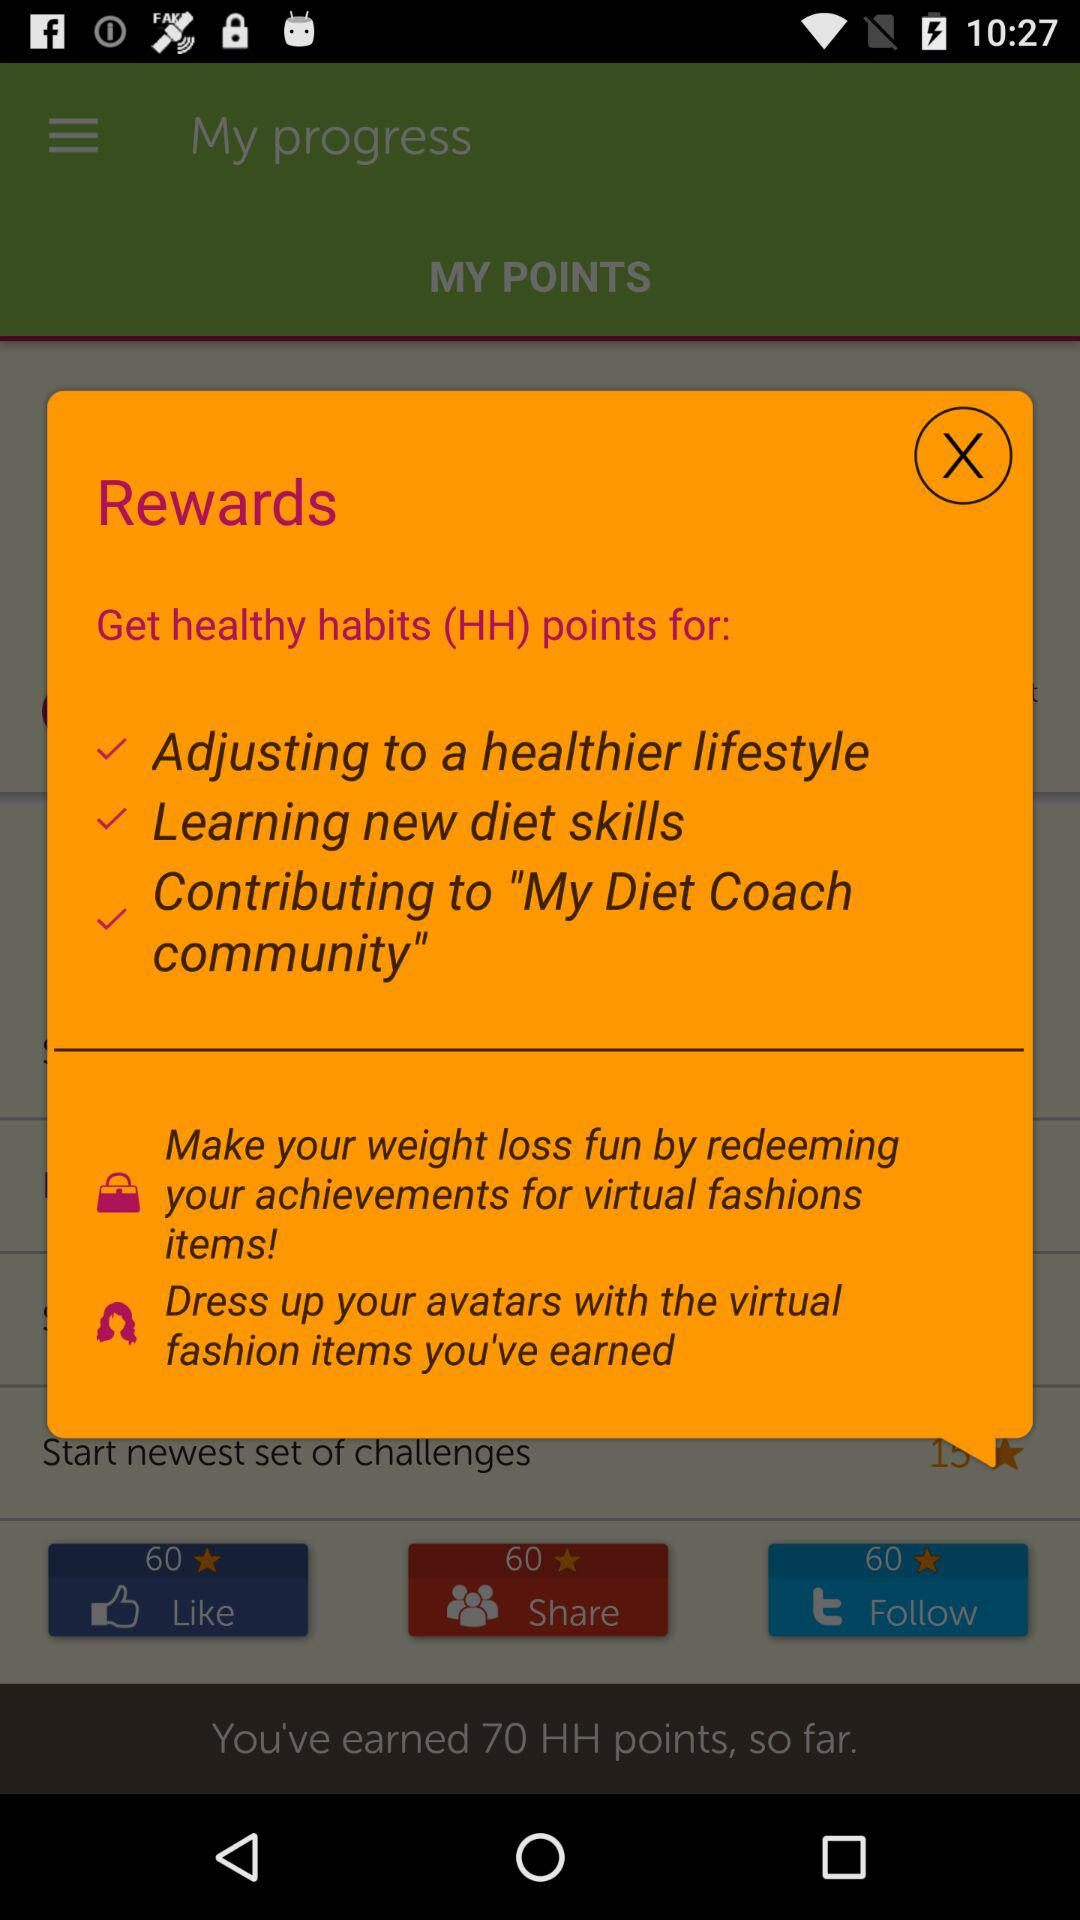What are the earned healthy habits points? There are 70 earned healthy habits points. 